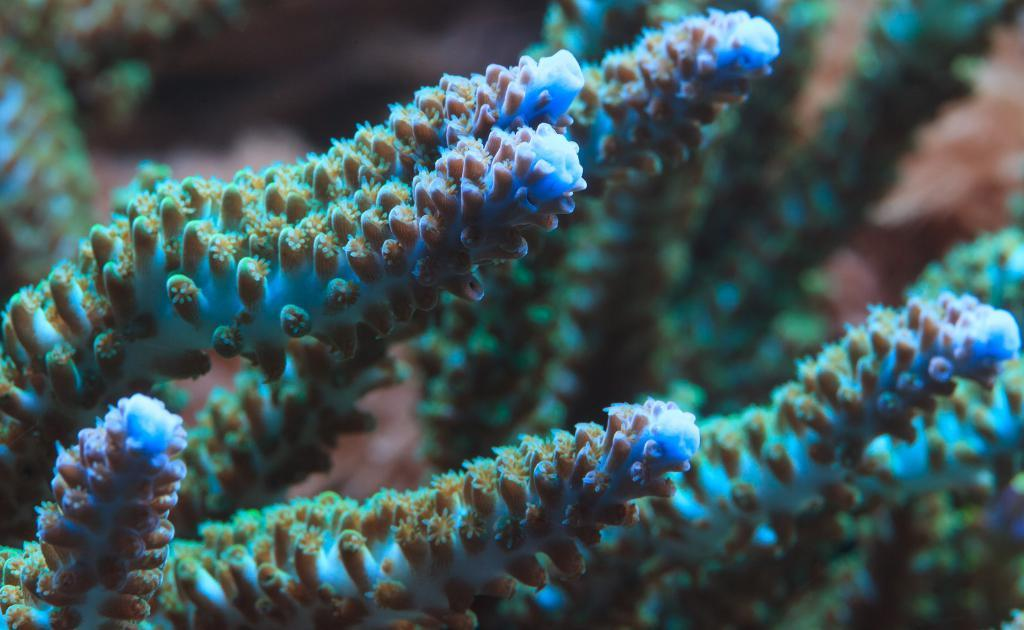What type of plants can be seen in the image? Water plants are present in the image. Are these plants typically found in a specific environment? Yes, water plants are typically found in aquatic environments. Can you describe the appearance of these plants? Water plants in the image may have leaves that float on the water surface or stems that grow underwater. What type of steel structure can be seen in the image? There is no steel structure present in the image; it features water plants. How many pigs are visible in the image? There are no pigs present in the image; it features water plants. 